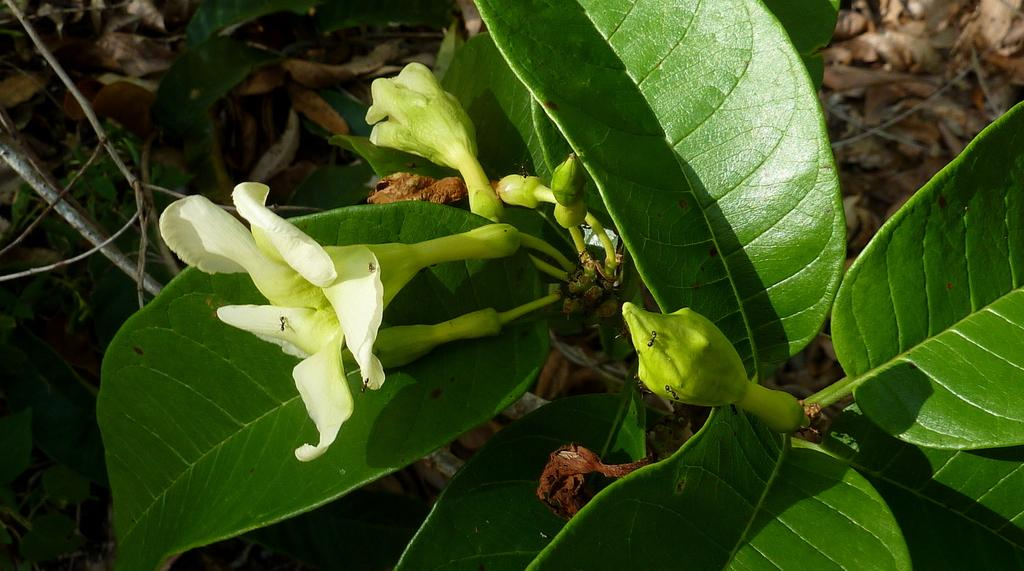What type of plant can be seen in the image? There is a green color plant in the image. What color is the flower on the plant? The flower on the plant is white in color. How does the plant help people understand the functioning of the brain in the image? The image does not show any connection between the plant and the functioning of the brain. 